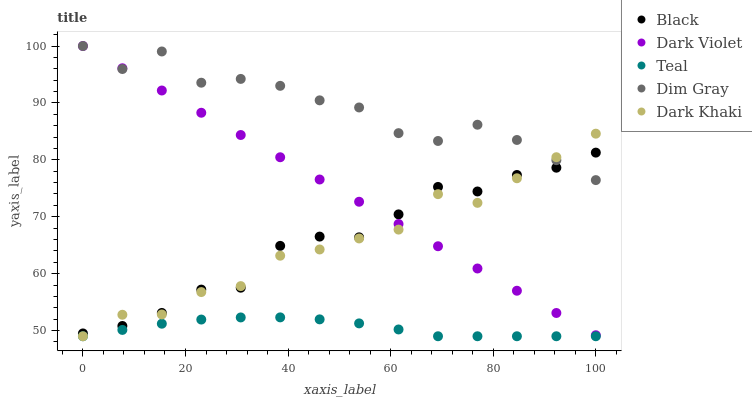Does Teal have the minimum area under the curve?
Answer yes or no. Yes. Does Dim Gray have the maximum area under the curve?
Answer yes or no. Yes. Does Black have the minimum area under the curve?
Answer yes or no. No. Does Black have the maximum area under the curve?
Answer yes or no. No. Is Dark Violet the smoothest?
Answer yes or no. Yes. Is Dim Gray the roughest?
Answer yes or no. Yes. Is Black the smoothest?
Answer yes or no. No. Is Black the roughest?
Answer yes or no. No. Does Dark Khaki have the lowest value?
Answer yes or no. Yes. Does Black have the lowest value?
Answer yes or no. No. Does Dark Violet have the highest value?
Answer yes or no. Yes. Does Black have the highest value?
Answer yes or no. No. Is Teal less than Black?
Answer yes or no. Yes. Is Dim Gray greater than Teal?
Answer yes or no. Yes. Does Dark Khaki intersect Teal?
Answer yes or no. Yes. Is Dark Khaki less than Teal?
Answer yes or no. No. Is Dark Khaki greater than Teal?
Answer yes or no. No. Does Teal intersect Black?
Answer yes or no. No. 